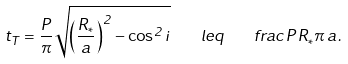<formula> <loc_0><loc_0><loc_500><loc_500>t _ { T } = \frac { P } { \pi } \sqrt { \left ( \frac { R _ { * } } { a } \right ) ^ { 2 } - \cos ^ { 2 } { i } } \quad l e q \quad f r a c { P \, R _ { * } } { \pi \, a } .</formula> 